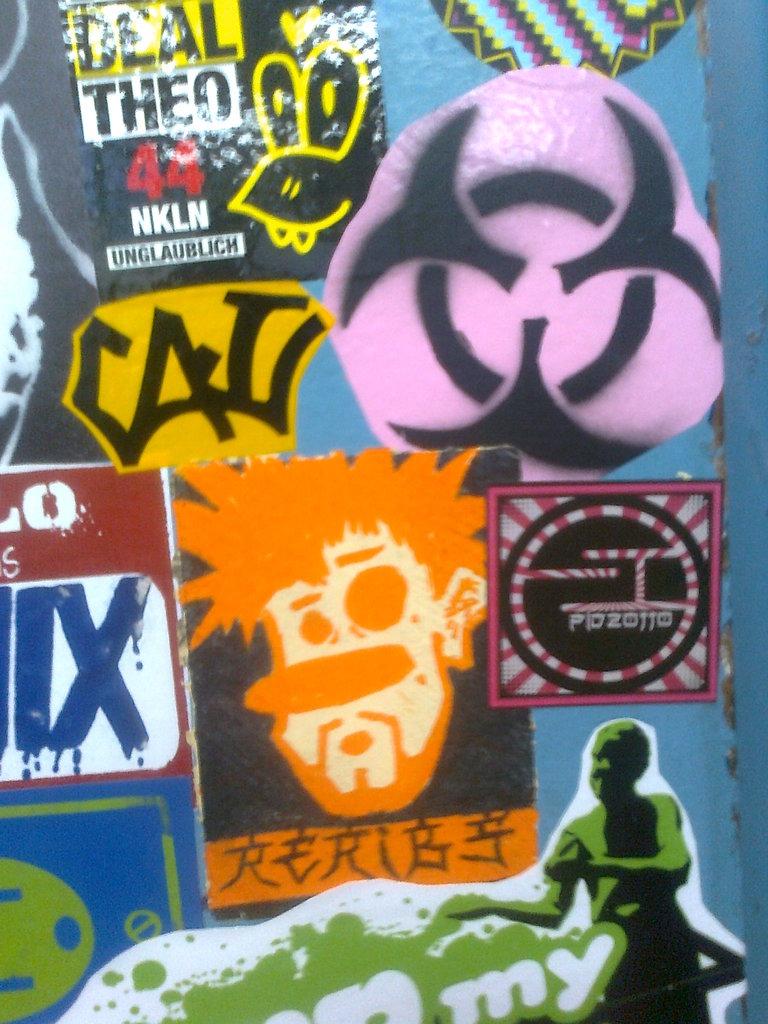What does the text in the yellow box say?
Offer a very short reply. Deal. What number is written in red?
Your answer should be very brief. 44. 